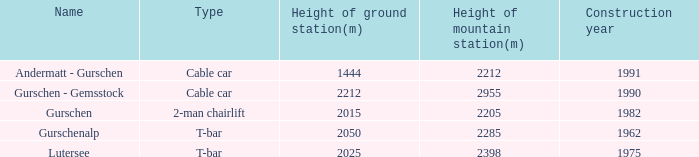What is the elevation (in meters) of the lutersee ground station, and is the elevation of its mountain station (in meters) more than 2398? 0.0. 